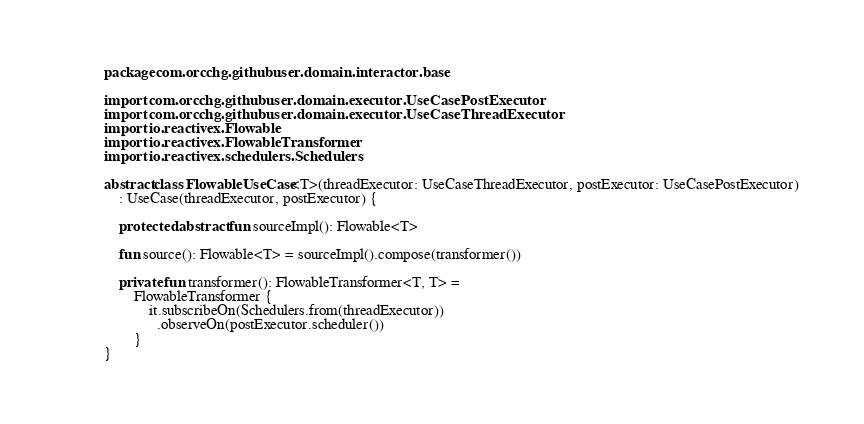<code> <loc_0><loc_0><loc_500><loc_500><_Kotlin_>package com.orcchg.githubuser.domain.interactor.base

import com.orcchg.githubuser.domain.executor.UseCasePostExecutor
import com.orcchg.githubuser.domain.executor.UseCaseThreadExecutor
import io.reactivex.Flowable
import io.reactivex.FlowableTransformer
import io.reactivex.schedulers.Schedulers

abstract class FlowableUseCase<T>(threadExecutor: UseCaseThreadExecutor, postExecutor: UseCasePostExecutor)
    : UseCase(threadExecutor, postExecutor) {

    protected abstract fun sourceImpl(): Flowable<T>

    fun source(): Flowable<T> = sourceImpl().compose(transformer())

    private fun transformer(): FlowableTransformer<T, T> =
        FlowableTransformer {
            it.subscribeOn(Schedulers.from(threadExecutor))
              .observeOn(postExecutor.scheduler())
        }
}
</code> 